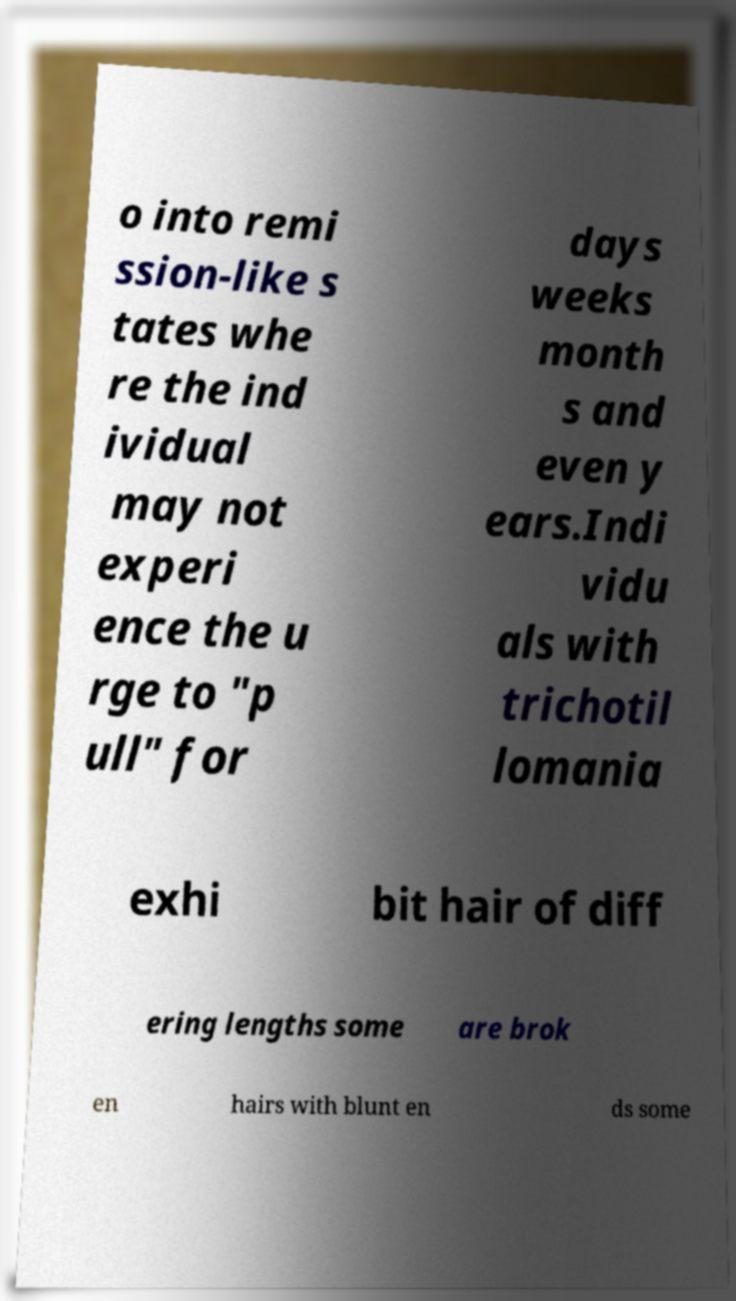Could you extract and type out the text from this image? o into remi ssion-like s tates whe re the ind ividual may not experi ence the u rge to "p ull" for days weeks month s and even y ears.Indi vidu als with trichotil lomania exhi bit hair of diff ering lengths some are brok en hairs with blunt en ds some 